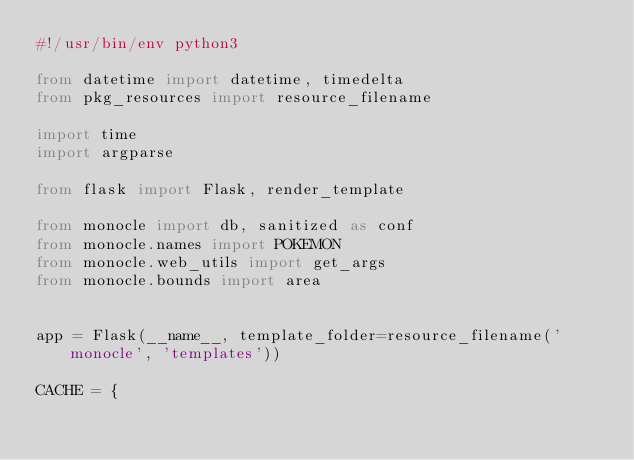Convert code to text. <code><loc_0><loc_0><loc_500><loc_500><_Python_>#!/usr/bin/env python3

from datetime import datetime, timedelta
from pkg_resources import resource_filename

import time
import argparse

from flask import Flask, render_template

from monocle import db, sanitized as conf
from monocle.names import POKEMON
from monocle.web_utils import get_args
from monocle.bounds import area


app = Flask(__name__, template_folder=resource_filename('monocle', 'templates'))

CACHE = {</code> 